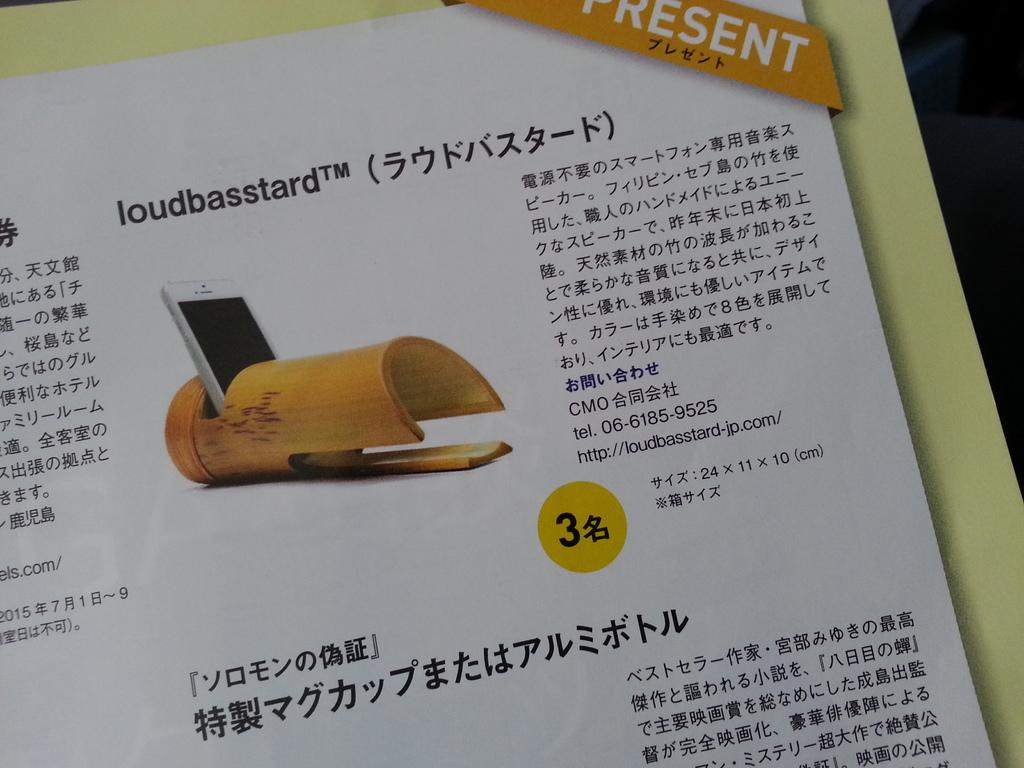<image>
Summarize the visual content of the image. Ad advertement for a phone product called the loudbasstard. 